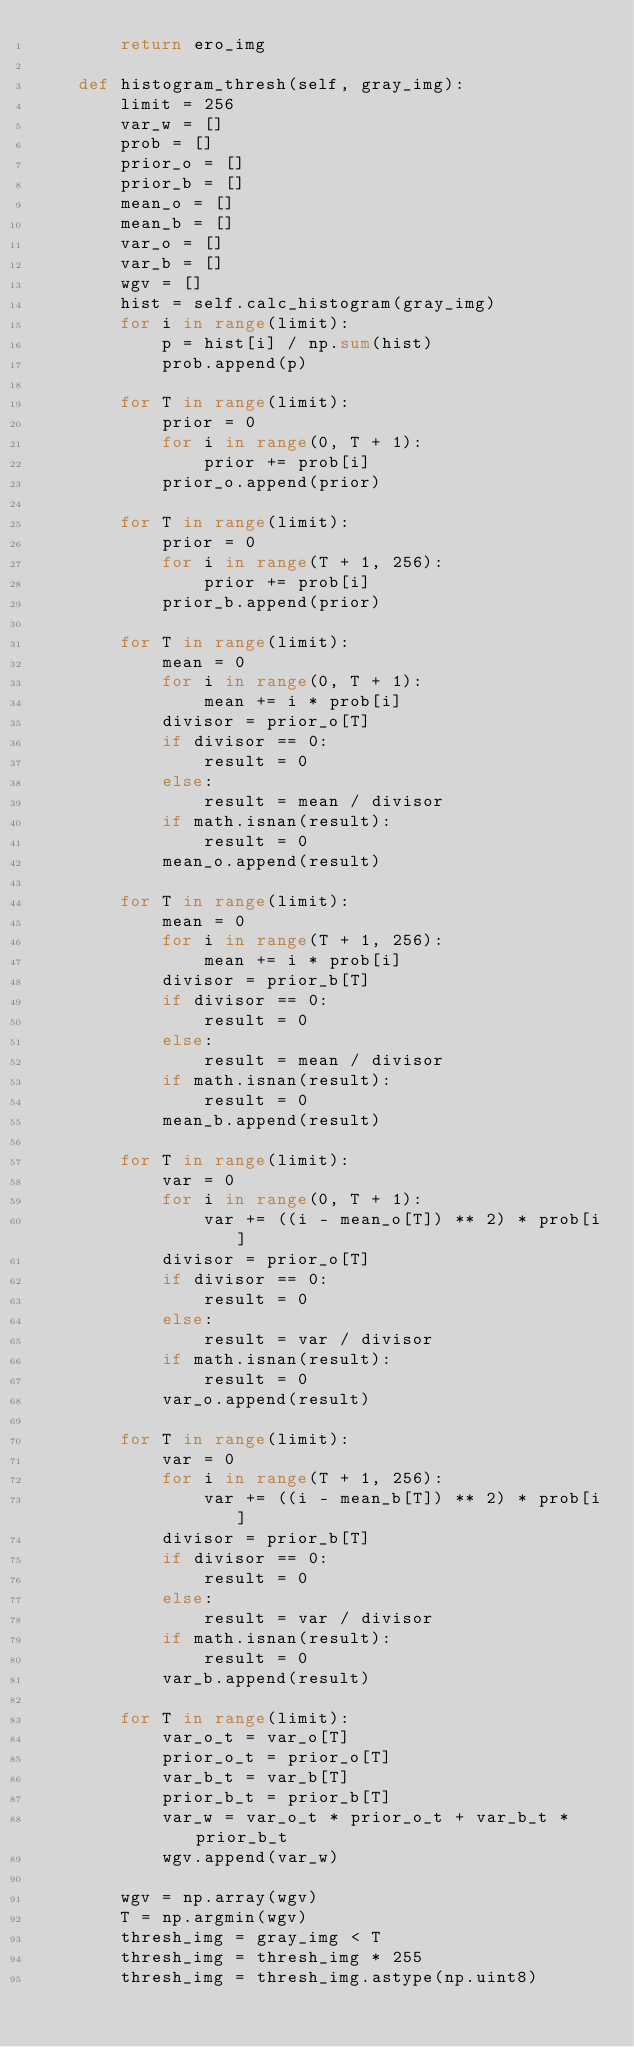<code> <loc_0><loc_0><loc_500><loc_500><_Python_>        return ero_img

    def histogram_thresh(self, gray_img):
        limit = 256
        var_w = []
        prob = []
        prior_o = []
        prior_b = []
        mean_o = []
        mean_b = []
        var_o = []
        var_b = []
        wgv = []
        hist = self.calc_histogram(gray_img)
        for i in range(limit):
            p = hist[i] / np.sum(hist)
            prob.append(p)

        for T in range(limit):
            prior = 0
            for i in range(0, T + 1):
                prior += prob[i]
            prior_o.append(prior)

        for T in range(limit):
            prior = 0
            for i in range(T + 1, 256):
                prior += prob[i]
            prior_b.append(prior)

        for T in range(limit):
            mean = 0
            for i in range(0, T + 1):
                mean += i * prob[i]
            divisor = prior_o[T]
            if divisor == 0:
                result = 0
            else:
                result = mean / divisor
            if math.isnan(result):
                result = 0
            mean_o.append(result)

        for T in range(limit):
            mean = 0
            for i in range(T + 1, 256):
                mean += i * prob[i]
            divisor = prior_b[T]
            if divisor == 0:
                result = 0
            else:
                result = mean / divisor
            if math.isnan(result):
                result = 0
            mean_b.append(result)

        for T in range(limit):
            var = 0
            for i in range(0, T + 1):
                var += ((i - mean_o[T]) ** 2) * prob[i]
            divisor = prior_o[T]
            if divisor == 0:
                result = 0
            else:
                result = var / divisor
            if math.isnan(result):
                result = 0
            var_o.append(result)

        for T in range(limit):
            var = 0
            for i in range(T + 1, 256):
                var += ((i - mean_b[T]) ** 2) * prob[i]
            divisor = prior_b[T]
            if divisor == 0:
                result = 0
            else:
                result = var / divisor
            if math.isnan(result):
                result = 0
            var_b.append(result)

        for T in range(limit):
            var_o_t = var_o[T]
            prior_o_t = prior_o[T]
            var_b_t = var_b[T]
            prior_b_t = prior_b[T]
            var_w = var_o_t * prior_o_t + var_b_t * prior_b_t
            wgv.append(var_w)

        wgv = np.array(wgv)
        T = np.argmin(wgv)
        thresh_img = gray_img < T
        thresh_img = thresh_img * 255
        thresh_img = thresh_img.astype(np.uint8)</code> 